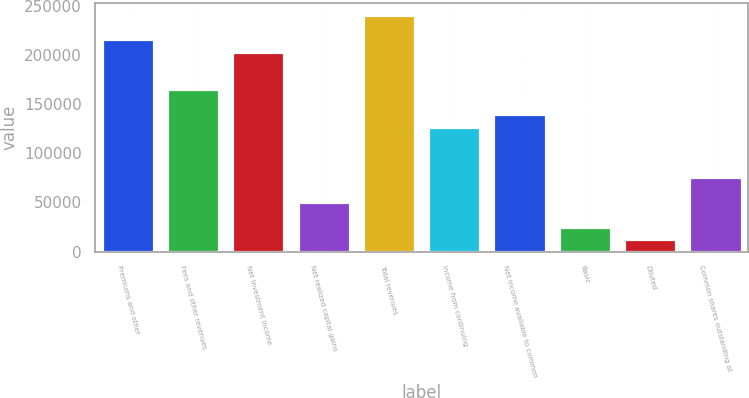Convert chart to OTSL. <chart><loc_0><loc_0><loc_500><loc_500><bar_chart><fcel>Premiums and other<fcel>Fees and other revenues<fcel>Net investment income<fcel>Net realized capital gains<fcel>Total revenues<fcel>Income from continuing<fcel>Net income available to common<fcel>Basic<fcel>Diluted<fcel>Common shares outstanding at<nl><fcel>215960<fcel>165146<fcel>203256<fcel>50814.5<fcel>241367<fcel>127035<fcel>139739<fcel>25407.6<fcel>12704.1<fcel>76221.5<nl></chart> 